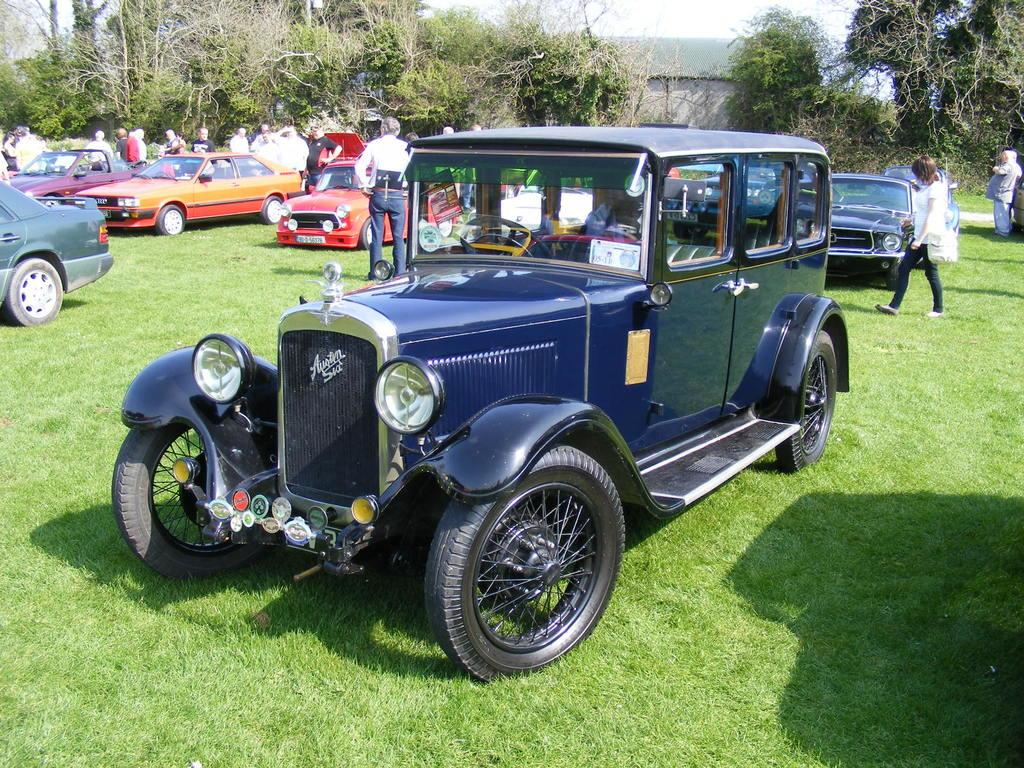What is the main subject of the image? The main subject of the image is a group of vehicles parked on the grass field. Are there any people present in the image? Yes, there are people standing near the vehicles. What can be seen in the background of the image? In the background, there is a building with a roof, a group of trees, and the sky. Can you tell me how many clovers are growing near the vehicles in the image? There is no mention of clovers in the image, so it is impossible to determine how many are growing near the vehicles. 